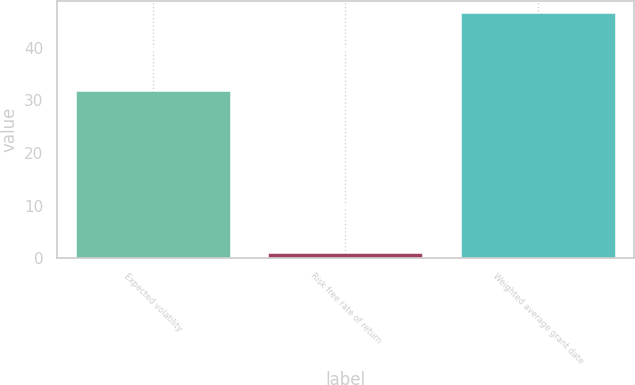Convert chart to OTSL. <chart><loc_0><loc_0><loc_500><loc_500><bar_chart><fcel>Expected volatility<fcel>Risk free rate of return<fcel>Weighted average grant date<nl><fcel>31.73<fcel>1.01<fcel>46.54<nl></chart> 